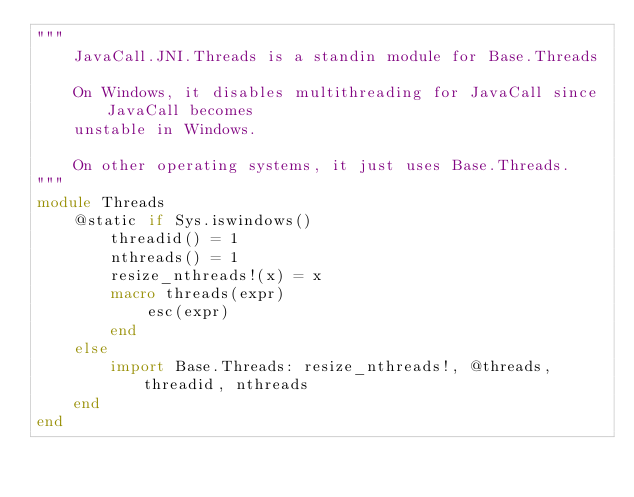Convert code to text. <code><loc_0><loc_0><loc_500><loc_500><_Julia_>"""
    JavaCall.JNI.Threads is a standin module for Base.Threads

    On Windows, it disables multithreading for JavaCall since JavaCall becomes
    unstable in Windows.

    On other operating systems, it just uses Base.Threads.
"""
module Threads
    @static if Sys.iswindows()
        threadid() = 1
        nthreads() = 1
        resize_nthreads!(x) = x
        macro threads(expr)
            esc(expr)
        end
    else
        import Base.Threads: resize_nthreads!, @threads, threadid, nthreads
    end
end</code> 